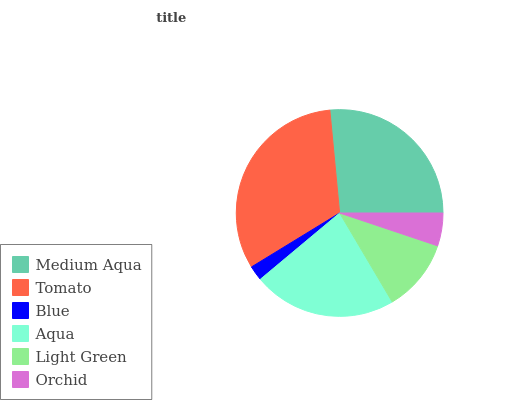Is Blue the minimum?
Answer yes or no. Yes. Is Tomato the maximum?
Answer yes or no. Yes. Is Tomato the minimum?
Answer yes or no. No. Is Blue the maximum?
Answer yes or no. No. Is Tomato greater than Blue?
Answer yes or no. Yes. Is Blue less than Tomato?
Answer yes or no. Yes. Is Blue greater than Tomato?
Answer yes or no. No. Is Tomato less than Blue?
Answer yes or no. No. Is Aqua the high median?
Answer yes or no. Yes. Is Light Green the low median?
Answer yes or no. Yes. Is Blue the high median?
Answer yes or no. No. Is Aqua the low median?
Answer yes or no. No. 